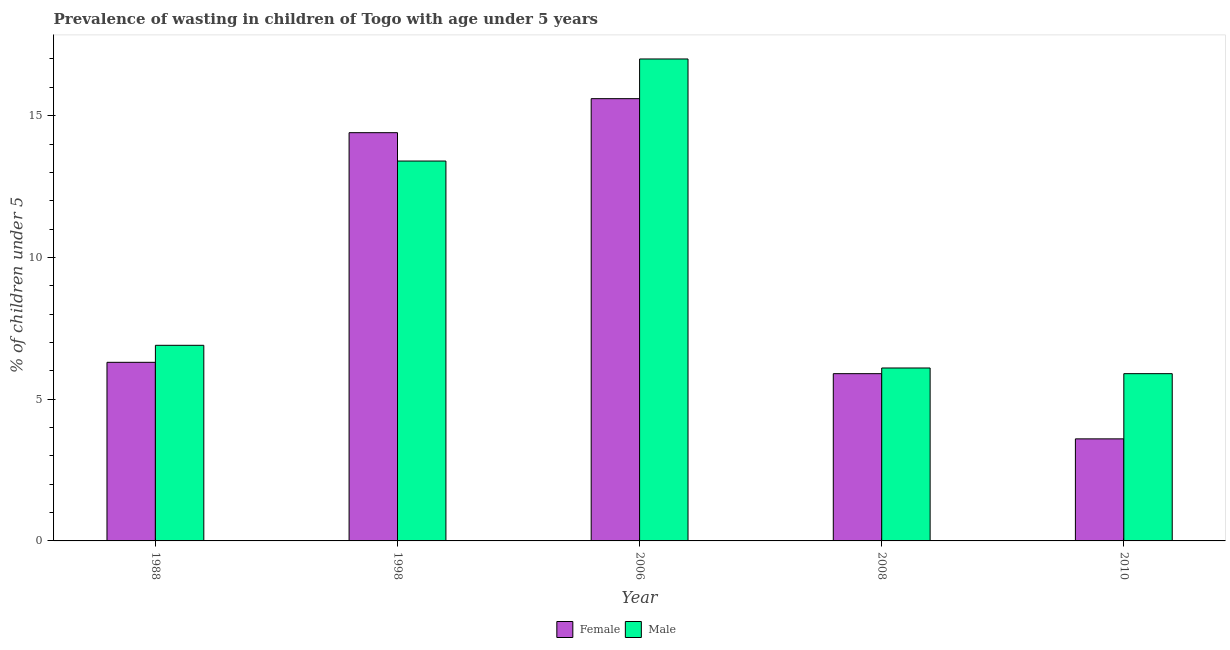Are the number of bars on each tick of the X-axis equal?
Offer a terse response. Yes. What is the label of the 2nd group of bars from the left?
Give a very brief answer. 1998. In how many cases, is the number of bars for a given year not equal to the number of legend labels?
Offer a very short reply. 0. What is the percentage of undernourished male children in 2008?
Provide a short and direct response. 6.1. Across all years, what is the minimum percentage of undernourished male children?
Offer a very short reply. 5.9. In which year was the percentage of undernourished female children minimum?
Provide a succinct answer. 2010. What is the total percentage of undernourished male children in the graph?
Keep it short and to the point. 49.3. What is the difference between the percentage of undernourished male children in 1998 and that in 2010?
Give a very brief answer. 7.5. What is the difference between the percentage of undernourished male children in 1988 and the percentage of undernourished female children in 2006?
Provide a short and direct response. -10.1. What is the average percentage of undernourished male children per year?
Offer a terse response. 9.86. In how many years, is the percentage of undernourished male children greater than 8 %?
Your answer should be very brief. 2. What is the ratio of the percentage of undernourished female children in 1998 to that in 2010?
Ensure brevity in your answer.  4. Is the difference between the percentage of undernourished female children in 2006 and 2008 greater than the difference between the percentage of undernourished male children in 2006 and 2008?
Your answer should be compact. No. What is the difference between the highest and the second highest percentage of undernourished male children?
Provide a short and direct response. 3.6. What is the difference between the highest and the lowest percentage of undernourished male children?
Ensure brevity in your answer.  11.1. What does the 2nd bar from the right in 2008 represents?
Make the answer very short. Female. How many bars are there?
Your answer should be compact. 10. Are all the bars in the graph horizontal?
Your answer should be very brief. No. How many years are there in the graph?
Offer a terse response. 5. What is the difference between two consecutive major ticks on the Y-axis?
Your answer should be very brief. 5. Are the values on the major ticks of Y-axis written in scientific E-notation?
Ensure brevity in your answer.  No. Does the graph contain any zero values?
Ensure brevity in your answer.  No. Does the graph contain grids?
Give a very brief answer. No. What is the title of the graph?
Provide a short and direct response. Prevalence of wasting in children of Togo with age under 5 years. Does "Time to import" appear as one of the legend labels in the graph?
Your answer should be very brief. No. What is the label or title of the X-axis?
Offer a very short reply. Year. What is the label or title of the Y-axis?
Your answer should be very brief.  % of children under 5. What is the  % of children under 5 in Female in 1988?
Your answer should be compact. 6.3. What is the  % of children under 5 of Male in 1988?
Provide a succinct answer. 6.9. What is the  % of children under 5 in Female in 1998?
Your response must be concise. 14.4. What is the  % of children under 5 in Male in 1998?
Make the answer very short. 13.4. What is the  % of children under 5 in Female in 2006?
Make the answer very short. 15.6. What is the  % of children under 5 in Male in 2006?
Offer a terse response. 17. What is the  % of children under 5 of Female in 2008?
Ensure brevity in your answer.  5.9. What is the  % of children under 5 in Male in 2008?
Your response must be concise. 6.1. What is the  % of children under 5 of Female in 2010?
Ensure brevity in your answer.  3.6. What is the  % of children under 5 in Male in 2010?
Your response must be concise. 5.9. Across all years, what is the maximum  % of children under 5 in Female?
Offer a terse response. 15.6. Across all years, what is the maximum  % of children under 5 of Male?
Your response must be concise. 17. Across all years, what is the minimum  % of children under 5 in Female?
Offer a terse response. 3.6. Across all years, what is the minimum  % of children under 5 of Male?
Make the answer very short. 5.9. What is the total  % of children under 5 in Female in the graph?
Offer a very short reply. 45.8. What is the total  % of children under 5 in Male in the graph?
Give a very brief answer. 49.3. What is the difference between the  % of children under 5 in Female in 1988 and that in 1998?
Make the answer very short. -8.1. What is the difference between the  % of children under 5 in Female in 1988 and that in 2006?
Make the answer very short. -9.3. What is the difference between the  % of children under 5 in Male in 1988 and that in 2006?
Give a very brief answer. -10.1. What is the difference between the  % of children under 5 of Female in 1988 and that in 2008?
Offer a very short reply. 0.4. What is the difference between the  % of children under 5 in Male in 1988 and that in 2008?
Provide a short and direct response. 0.8. What is the difference between the  % of children under 5 of Female in 1988 and that in 2010?
Give a very brief answer. 2.7. What is the difference between the  % of children under 5 of Male in 1988 and that in 2010?
Your answer should be compact. 1. What is the difference between the  % of children under 5 of Male in 1998 and that in 2006?
Your answer should be very brief. -3.6. What is the difference between the  % of children under 5 in Male in 1998 and that in 2010?
Make the answer very short. 7.5. What is the difference between the  % of children under 5 of Female in 2006 and that in 2008?
Your response must be concise. 9.7. What is the difference between the  % of children under 5 of Male in 2006 and that in 2010?
Provide a short and direct response. 11.1. What is the difference between the  % of children under 5 in Female in 2008 and that in 2010?
Your answer should be very brief. 2.3. What is the difference between the  % of children under 5 in Male in 2008 and that in 2010?
Give a very brief answer. 0.2. What is the difference between the  % of children under 5 in Female in 1988 and the  % of children under 5 in Male in 2006?
Keep it short and to the point. -10.7. What is the difference between the  % of children under 5 of Female in 1998 and the  % of children under 5 of Male in 2010?
Ensure brevity in your answer.  8.5. What is the average  % of children under 5 in Female per year?
Offer a very short reply. 9.16. What is the average  % of children under 5 of Male per year?
Your answer should be compact. 9.86. In the year 1988, what is the difference between the  % of children under 5 in Female and  % of children under 5 in Male?
Provide a short and direct response. -0.6. In the year 1998, what is the difference between the  % of children under 5 in Female and  % of children under 5 in Male?
Give a very brief answer. 1. In the year 2010, what is the difference between the  % of children under 5 in Female and  % of children under 5 in Male?
Offer a terse response. -2.3. What is the ratio of the  % of children under 5 of Female in 1988 to that in 1998?
Provide a short and direct response. 0.44. What is the ratio of the  % of children under 5 in Male in 1988 to that in 1998?
Give a very brief answer. 0.51. What is the ratio of the  % of children under 5 in Female in 1988 to that in 2006?
Offer a terse response. 0.4. What is the ratio of the  % of children under 5 in Male in 1988 to that in 2006?
Provide a short and direct response. 0.41. What is the ratio of the  % of children under 5 of Female in 1988 to that in 2008?
Offer a terse response. 1.07. What is the ratio of the  % of children under 5 of Male in 1988 to that in 2008?
Offer a very short reply. 1.13. What is the ratio of the  % of children under 5 of Male in 1988 to that in 2010?
Provide a short and direct response. 1.17. What is the ratio of the  % of children under 5 in Male in 1998 to that in 2006?
Provide a succinct answer. 0.79. What is the ratio of the  % of children under 5 of Female in 1998 to that in 2008?
Make the answer very short. 2.44. What is the ratio of the  % of children under 5 of Male in 1998 to that in 2008?
Provide a short and direct response. 2.2. What is the ratio of the  % of children under 5 in Female in 1998 to that in 2010?
Ensure brevity in your answer.  4. What is the ratio of the  % of children under 5 of Male in 1998 to that in 2010?
Ensure brevity in your answer.  2.27. What is the ratio of the  % of children under 5 of Female in 2006 to that in 2008?
Your answer should be very brief. 2.64. What is the ratio of the  % of children under 5 of Male in 2006 to that in 2008?
Make the answer very short. 2.79. What is the ratio of the  % of children under 5 in Female in 2006 to that in 2010?
Provide a succinct answer. 4.33. What is the ratio of the  % of children under 5 of Male in 2006 to that in 2010?
Keep it short and to the point. 2.88. What is the ratio of the  % of children under 5 in Female in 2008 to that in 2010?
Give a very brief answer. 1.64. What is the ratio of the  % of children under 5 of Male in 2008 to that in 2010?
Keep it short and to the point. 1.03. What is the difference between the highest and the second highest  % of children under 5 in Male?
Give a very brief answer. 3.6. What is the difference between the highest and the lowest  % of children under 5 in Female?
Keep it short and to the point. 12. What is the difference between the highest and the lowest  % of children under 5 of Male?
Provide a short and direct response. 11.1. 